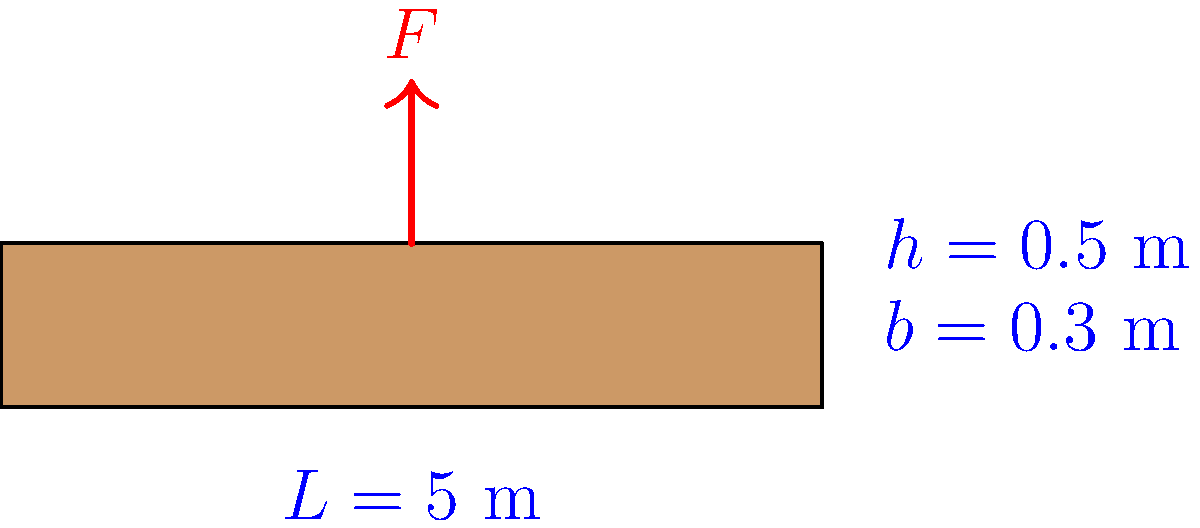As a telenovela producer always on the lookout for new talent, you're considering a dramatic scene where an actor must dramatically calculate the maximum load a beam can support. Given a simply supported concrete beam with a length $L = 5$ m, width $b = 0.3$ m, and height $h = 0.5$ m, what is the maximum concentrated load $F$ (in kN) that can be applied at the center of the beam if the allowable bending stress for concrete is $\sigma_{allow} = 10$ MPa? Assume the beam's self-weight is negligible. Let's approach this step-by-step, just like we'd build suspense in a telenovela:

1) The maximum bending moment $M_{max}$ for a simply supported beam with a concentrated load $F$ at the center is:

   $$M_{max} = \frac{FL}{4}$$

2) The section modulus $S$ for a rectangular beam is:

   $$S = \frac{bh^2}{6}$$

3) The maximum bending stress $\sigma_{max}$ is related to the maximum moment and section modulus:

   $$\sigma_{max} = \frac{M_{max}}{S}$$

4) We want the maximum stress to equal the allowable stress:

   $$\sigma_{allow} = \frac{M_{max}}{S} = \frac{FL/4}{bh^2/6}$$

5) Solving for $F$:

   $$F = \frac{4\sigma_{allow}bh^2}{6L}$$

6) Now, let's substitute our values:
   $\sigma_{allow} = 10$ MPa = 10,000 kPa
   $b = 0.3$ m
   $h = 0.5$ m
   $L = 5$ m

   $$F = \frac{4 \cdot 10,000 \cdot 0.3 \cdot 0.5^2}{6 \cdot 5} = 250 \text{ kN}$$

Thus, the maximum concentrated load the beam can support is 250 kN.
Answer: 250 kN 